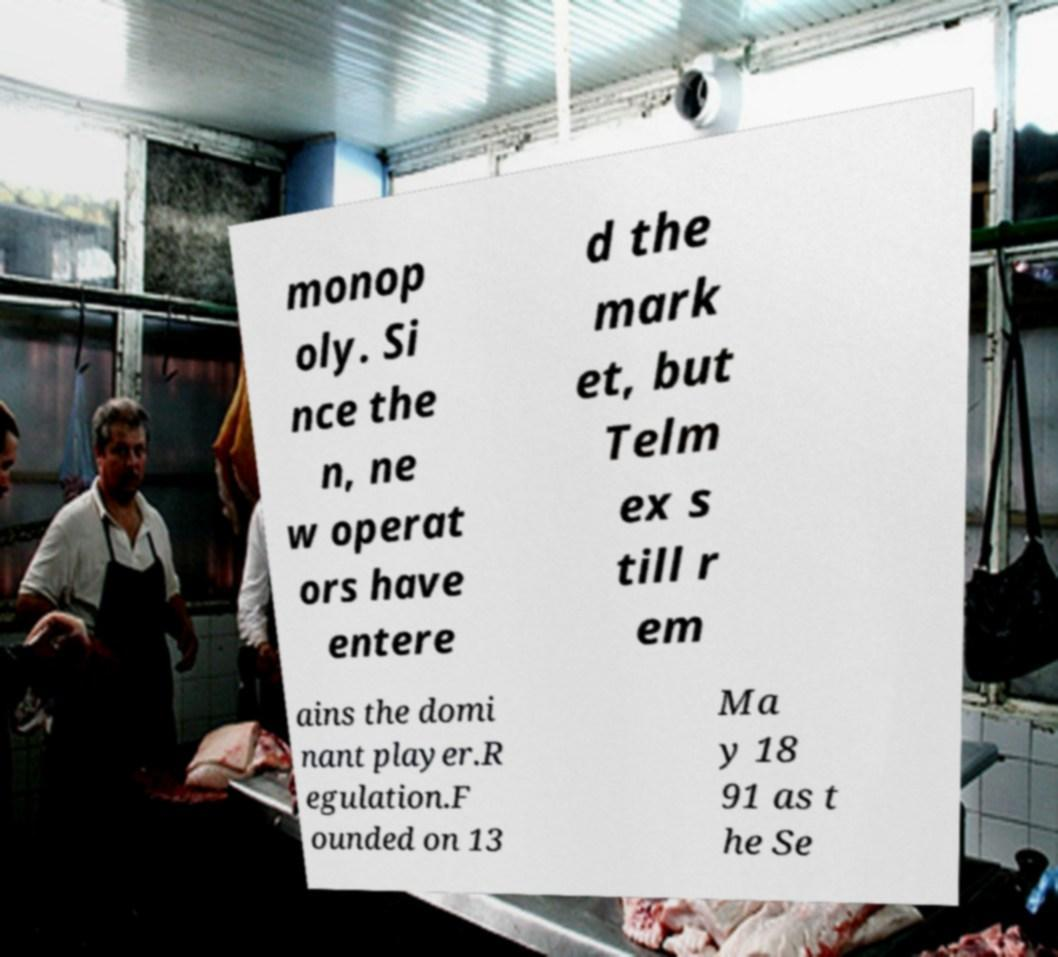For documentation purposes, I need the text within this image transcribed. Could you provide that? monop oly. Si nce the n, ne w operat ors have entere d the mark et, but Telm ex s till r em ains the domi nant player.R egulation.F ounded on 13 Ma y 18 91 as t he Se 